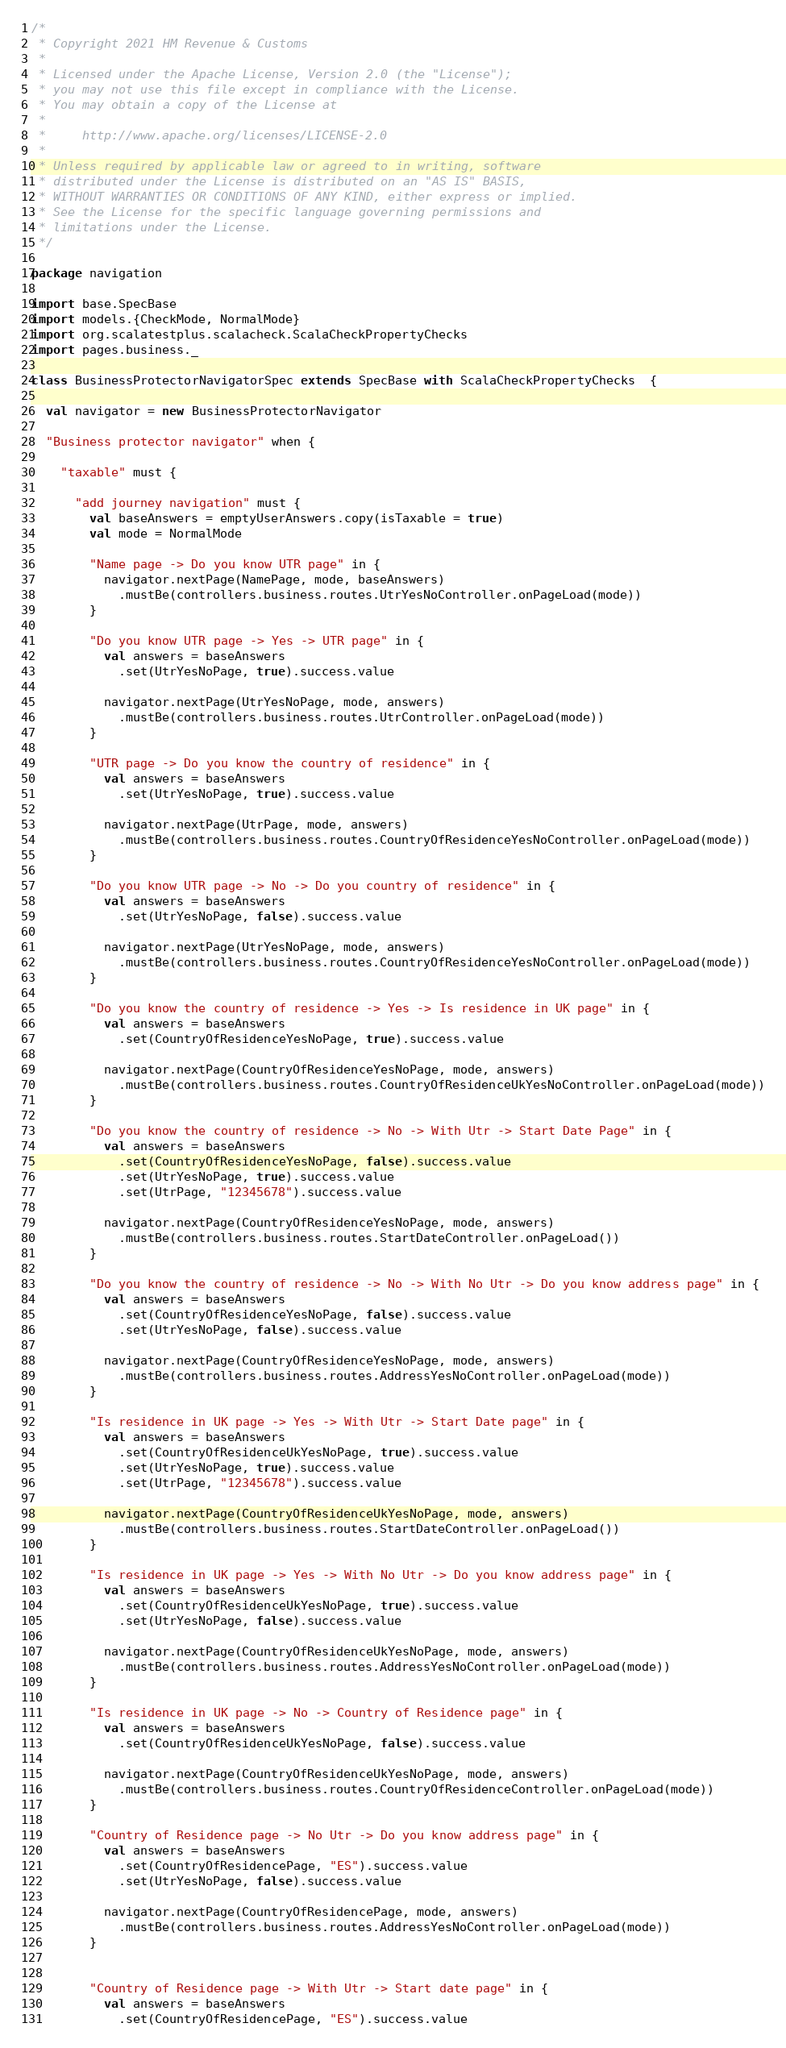Convert code to text. <code><loc_0><loc_0><loc_500><loc_500><_Scala_>/*
 * Copyright 2021 HM Revenue & Customs
 *
 * Licensed under the Apache License, Version 2.0 (the "License");
 * you may not use this file except in compliance with the License.
 * You may obtain a copy of the License at
 *
 *     http://www.apache.org/licenses/LICENSE-2.0
 *
 * Unless required by applicable law or agreed to in writing, software
 * distributed under the License is distributed on an "AS IS" BASIS,
 * WITHOUT WARRANTIES OR CONDITIONS OF ANY KIND, either express or implied.
 * See the License for the specific language governing permissions and
 * limitations under the License.
 */

package navigation

import base.SpecBase
import models.{CheckMode, NormalMode}
import org.scalatestplus.scalacheck.ScalaCheckPropertyChecks
import pages.business._

class BusinessProtectorNavigatorSpec extends SpecBase with ScalaCheckPropertyChecks  {

  val navigator = new BusinessProtectorNavigator

  "Business protector navigator" when {

    "taxable" must {

      "add journey navigation" must {
        val baseAnswers = emptyUserAnswers.copy(isTaxable = true)
        val mode = NormalMode

        "Name page -> Do you know UTR page" in {
          navigator.nextPage(NamePage, mode, baseAnswers)
            .mustBe(controllers.business.routes.UtrYesNoController.onPageLoad(mode))
        }

        "Do you know UTR page -> Yes -> UTR page" in {
          val answers = baseAnswers
            .set(UtrYesNoPage, true).success.value

          navigator.nextPage(UtrYesNoPage, mode, answers)
            .mustBe(controllers.business.routes.UtrController.onPageLoad(mode))
        }

        "UTR page -> Do you know the country of residence" in {
          val answers = baseAnswers
            .set(UtrYesNoPage, true).success.value

          navigator.nextPage(UtrPage, mode, answers)
            .mustBe(controllers.business.routes.CountryOfResidenceYesNoController.onPageLoad(mode))
        }

        "Do you know UTR page -> No -> Do you country of residence" in {
          val answers = baseAnswers
            .set(UtrYesNoPage, false).success.value

          navigator.nextPage(UtrYesNoPage, mode, answers)
            .mustBe(controllers.business.routes.CountryOfResidenceYesNoController.onPageLoad(mode))
        }

        "Do you know the country of residence -> Yes -> Is residence in UK page" in {
          val answers = baseAnswers
            .set(CountryOfResidenceYesNoPage, true).success.value

          navigator.nextPage(CountryOfResidenceYesNoPage, mode, answers)
            .mustBe(controllers.business.routes.CountryOfResidenceUkYesNoController.onPageLoad(mode))
        }

        "Do you know the country of residence -> No -> With Utr -> Start Date Page" in {
          val answers = baseAnswers
            .set(CountryOfResidenceYesNoPage, false).success.value
            .set(UtrYesNoPage, true).success.value
            .set(UtrPage, "12345678").success.value

          navigator.nextPage(CountryOfResidenceYesNoPage, mode, answers)
            .mustBe(controllers.business.routes.StartDateController.onPageLoad())
        }

        "Do you know the country of residence -> No -> With No Utr -> Do you know address page" in {
          val answers = baseAnswers
            .set(CountryOfResidenceYesNoPage, false).success.value
            .set(UtrYesNoPage, false).success.value

          navigator.nextPage(CountryOfResidenceYesNoPage, mode, answers)
            .mustBe(controllers.business.routes.AddressYesNoController.onPageLoad(mode))
        }

        "Is residence in UK page -> Yes -> With Utr -> Start Date page" in {
          val answers = baseAnswers
            .set(CountryOfResidenceUkYesNoPage, true).success.value
            .set(UtrYesNoPage, true).success.value
            .set(UtrPage, "12345678").success.value

          navigator.nextPage(CountryOfResidenceUkYesNoPage, mode, answers)
            .mustBe(controllers.business.routes.StartDateController.onPageLoad())
        }
        
        "Is residence in UK page -> Yes -> With No Utr -> Do you know address page" in {
          val answers = baseAnswers
            .set(CountryOfResidenceUkYesNoPage, true).success.value
            .set(UtrYesNoPage, false).success.value
          
          navigator.nextPage(CountryOfResidenceUkYesNoPage, mode, answers)
            .mustBe(controllers.business.routes.AddressYesNoController.onPageLoad(mode))
        }

        "Is residence in UK page -> No -> Country of Residence page" in {
          val answers = baseAnswers
            .set(CountryOfResidenceUkYesNoPage, false).success.value

          navigator.nextPage(CountryOfResidenceUkYesNoPage, mode, answers)
            .mustBe(controllers.business.routes.CountryOfResidenceController.onPageLoad(mode))
        }

        "Country of Residence page -> No Utr -> Do you know address page" in {
          val answers = baseAnswers
            .set(CountryOfResidencePage, "ES").success.value
            .set(UtrYesNoPage, false).success.value

          navigator.nextPage(CountryOfResidencePage, mode, answers)
            .mustBe(controllers.business.routes.AddressYesNoController.onPageLoad(mode))
        }
        

        "Country of Residence page -> With Utr -> Start date page" in {
          val answers = baseAnswers
            .set(CountryOfResidencePage, "ES").success.value</code> 